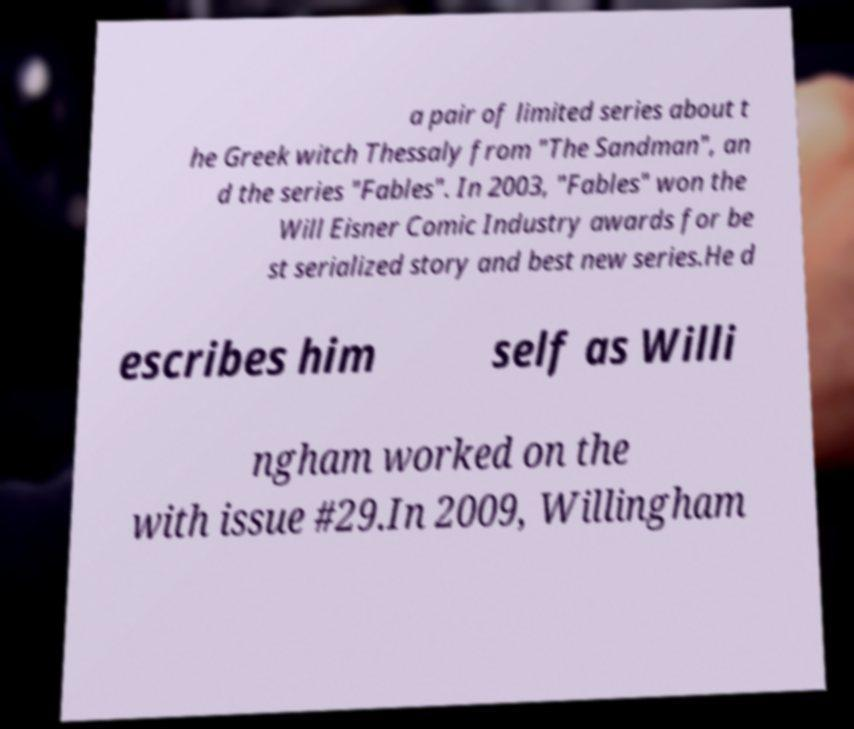I need the written content from this picture converted into text. Can you do that? a pair of limited series about t he Greek witch Thessaly from "The Sandman", an d the series "Fables". In 2003, "Fables" won the Will Eisner Comic Industry awards for be st serialized story and best new series.He d escribes him self as Willi ngham worked on the with issue #29.In 2009, Willingham 